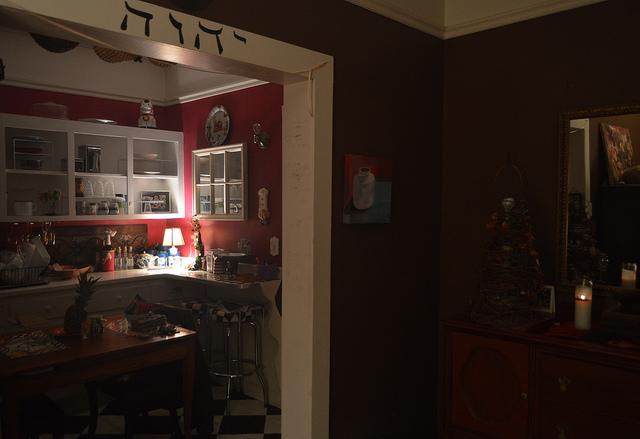Is the lamp off?
Answer briefly. No. What color are the walls in the picture?
Quick response, please. Red. Is there a lot of light?
Be succinct. No. 